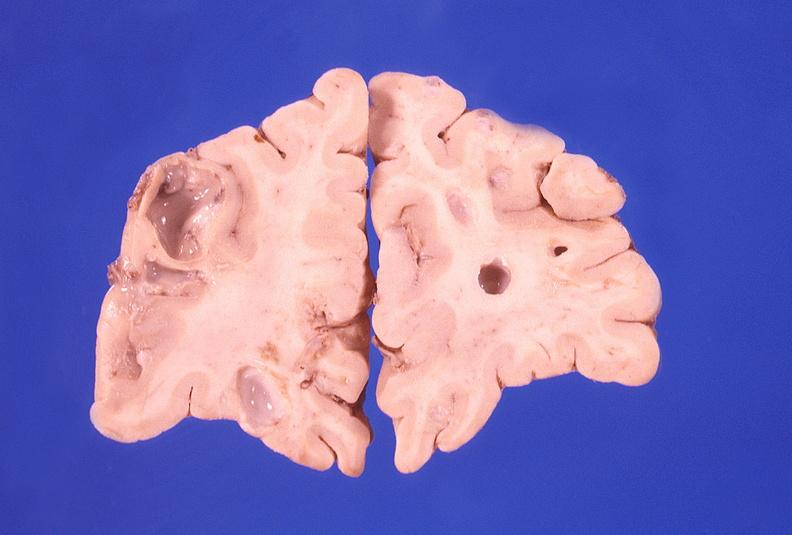does this image show brain abscess?
Answer the question using a single word or phrase. Yes 